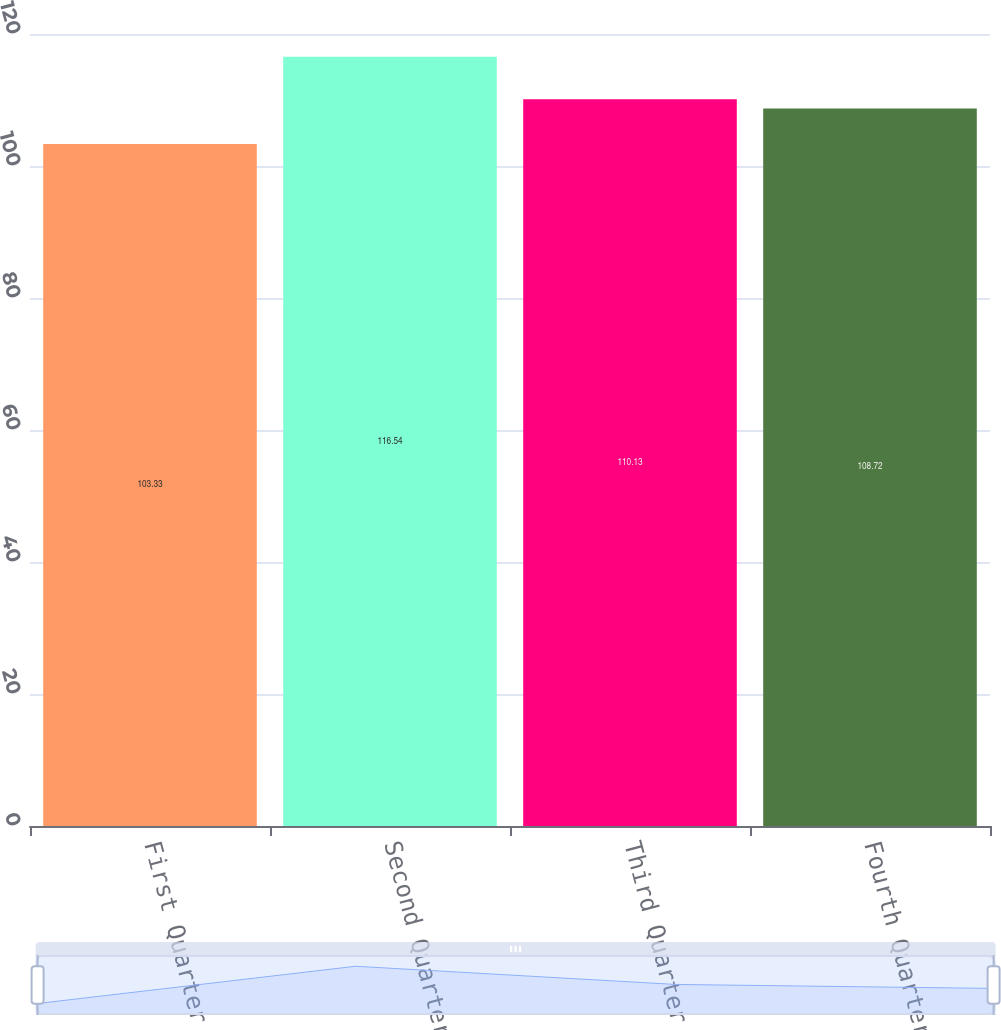<chart> <loc_0><loc_0><loc_500><loc_500><bar_chart><fcel>First Quarter<fcel>Second Quarter<fcel>Third Quarter<fcel>Fourth Quarter<nl><fcel>103.33<fcel>116.54<fcel>110.13<fcel>108.72<nl></chart> 